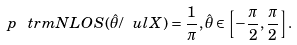Convert formula to latex. <formula><loc_0><loc_0><loc_500><loc_500>p _ { \ } t r m { N L O S } ( \hat { \theta } / \ u l { X } ) = \frac { 1 } { \pi } , \hat { \theta } \in \left [ - \frac { \pi } { 2 } , \frac { \pi } { 2 } \right ] .</formula> 